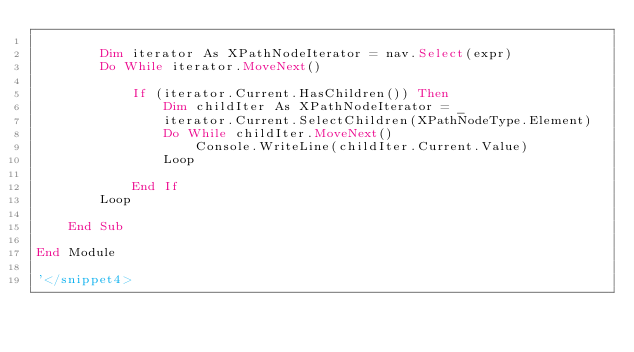Convert code to text. <code><loc_0><loc_0><loc_500><loc_500><_VisualBasic_>
        Dim iterator As XPathNodeIterator = nav.Select(expr)
        Do While iterator.MoveNext()

            If (iterator.Current.HasChildren()) Then
                Dim childIter As XPathNodeIterator = _
                iterator.Current.SelectChildren(XPathNodeType.Element)
                Do While childIter.MoveNext()
                    Console.WriteLine(childIter.Current.Value)
                Loop

            End If
        Loop

    End Sub

End Module

'</snippet4>
</code> 